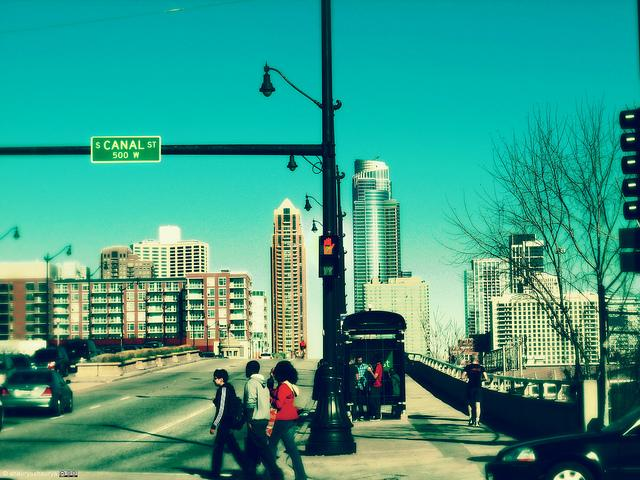What is the hand on the traffic light telling those facing it? stop 